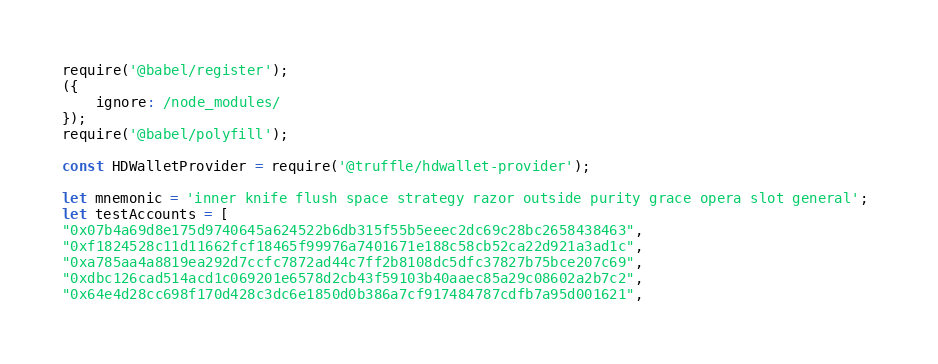Convert code to text. <code><loc_0><loc_0><loc_500><loc_500><_JavaScript_>require('@babel/register');
({
    ignore: /node_modules/
});
require('@babel/polyfill');

const HDWalletProvider = require('@truffle/hdwallet-provider');

let mnemonic = 'inner knife flush space strategy razor outside purity grace opera slot general'; 
let testAccounts = [
"0x07b4a69d8e175d9740645a624522b6db315f55b5eeec2dc69c28bc2658438463",
"0xf1824528c11d11662fcf18465f99976a7401671e188c58cb52ca22d921a3ad1c",
"0xa785aa4a8819ea292d7ccfc7872ad44c7ff2b8108dc5dfc37827b75bce207c69",
"0xdbc126cad514acd1c069201e6578d2cb43f59103b40aaec85a29c08602a2b7c2",
"0x64e4d28cc698f170d428c3dc6e1850d0b386a7cf917484787cdfb7a95d001621",</code> 